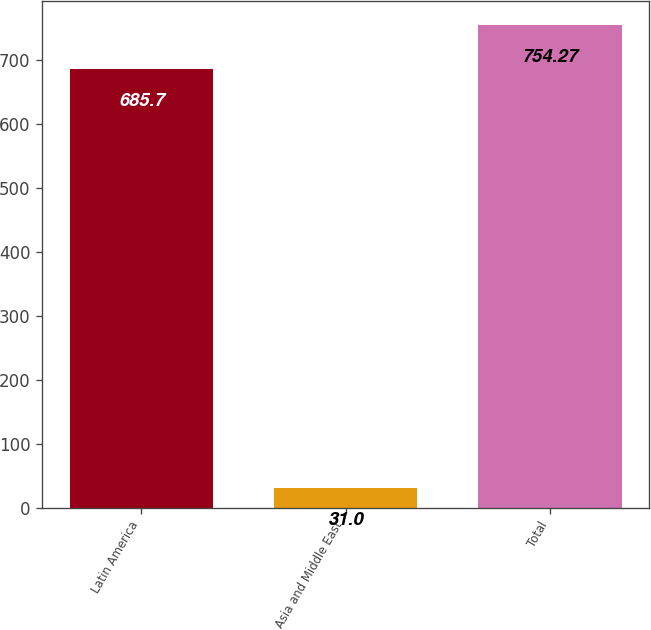Convert chart. <chart><loc_0><loc_0><loc_500><loc_500><bar_chart><fcel>Latin America<fcel>Asia and Middle East<fcel>Total<nl><fcel>685.7<fcel>31<fcel>754.27<nl></chart> 